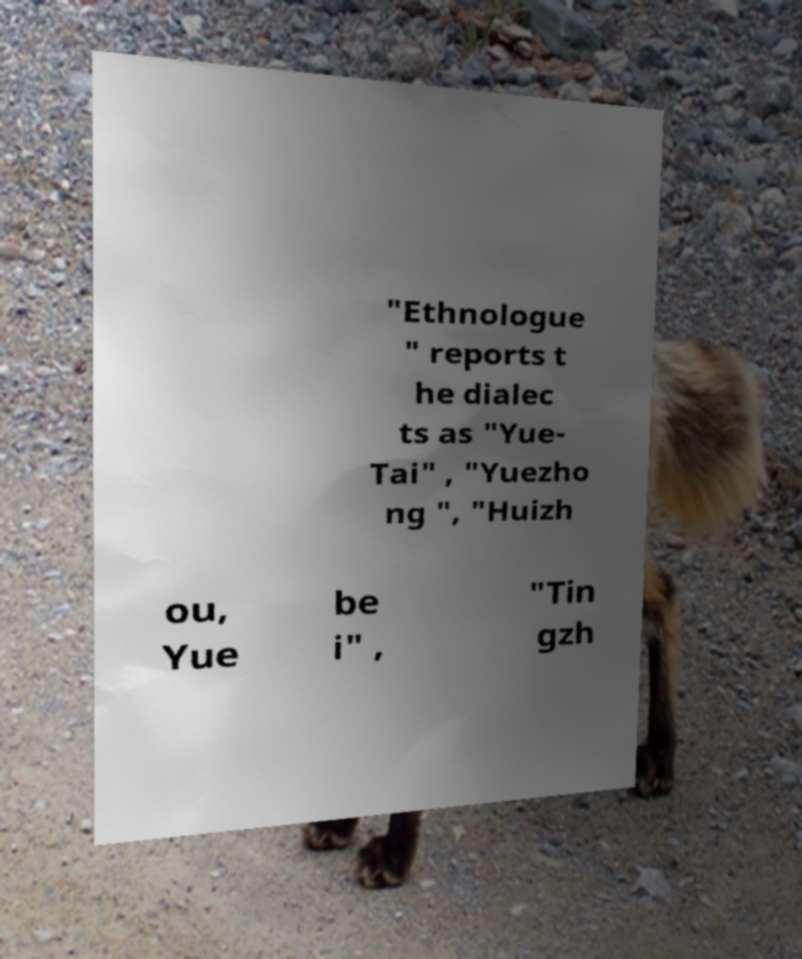Could you assist in decoding the text presented in this image and type it out clearly? "Ethnologue " reports t he dialec ts as "Yue- Tai" , "Yuezho ng ", "Huizh ou, Yue be i" , "Tin gzh 